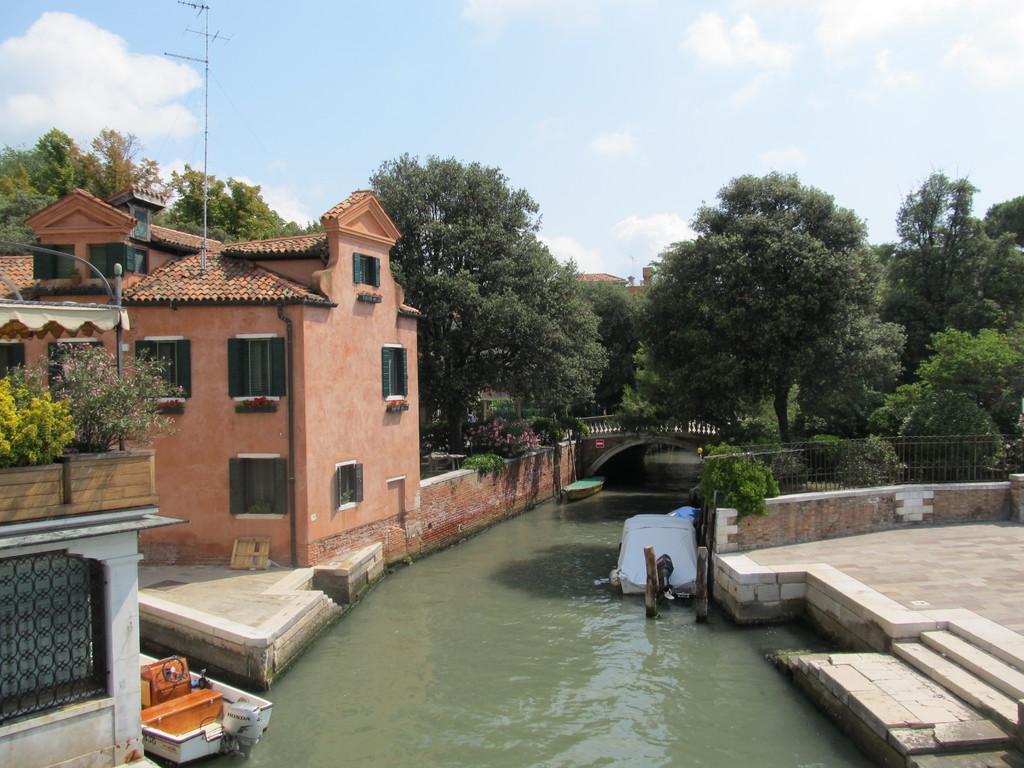In one or two sentences, can you explain what this image depicts? In the center of the image there are boats and there is a car in the water. There are wooden poles. On the right side of the image there is a metal fence. There are stairs. On the left side of the image there are buildings. There are plants. In the background of the image there is a bridge. There are trees. At the top of the image there is sky. 